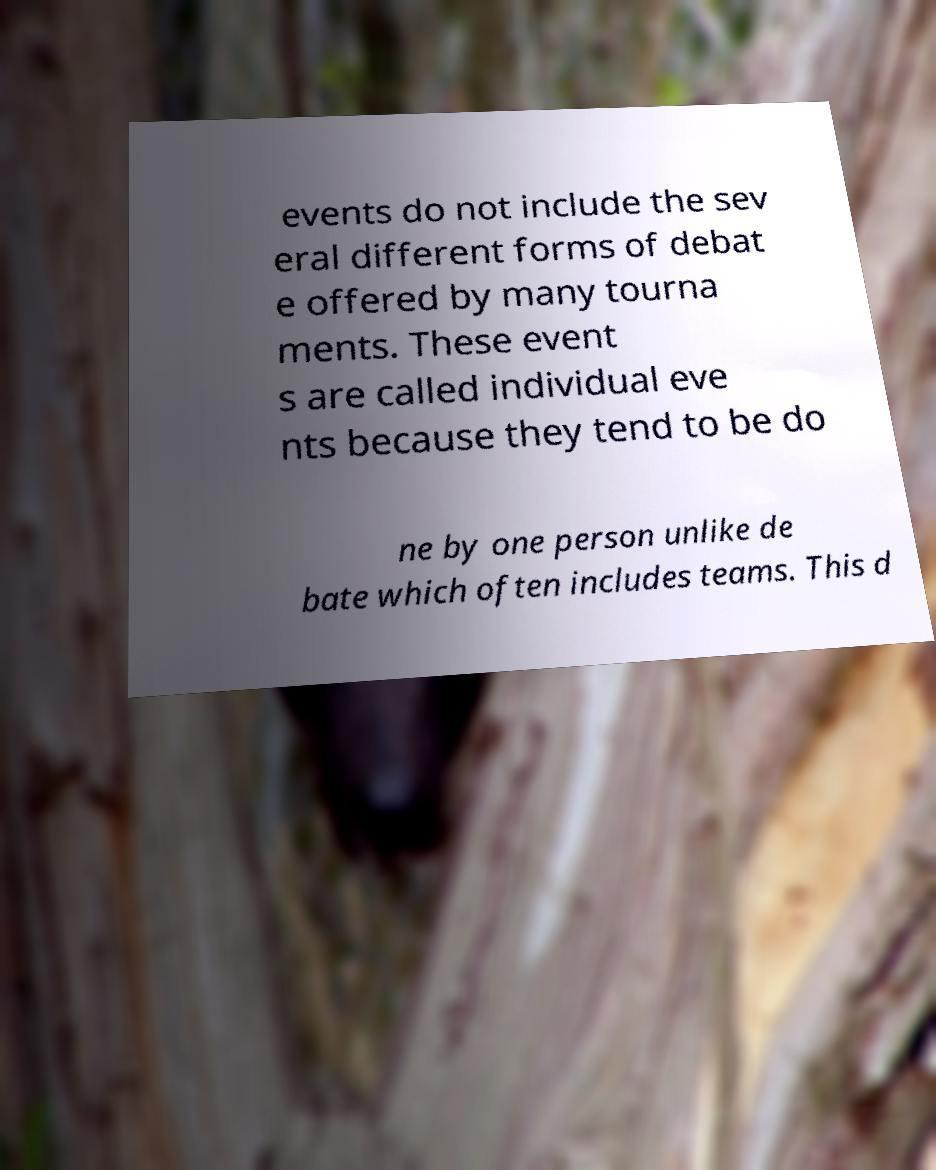Can you read and provide the text displayed in the image?This photo seems to have some interesting text. Can you extract and type it out for me? events do not include the sev eral different forms of debat e offered by many tourna ments. These event s are called individual eve nts because they tend to be do ne by one person unlike de bate which often includes teams. This d 